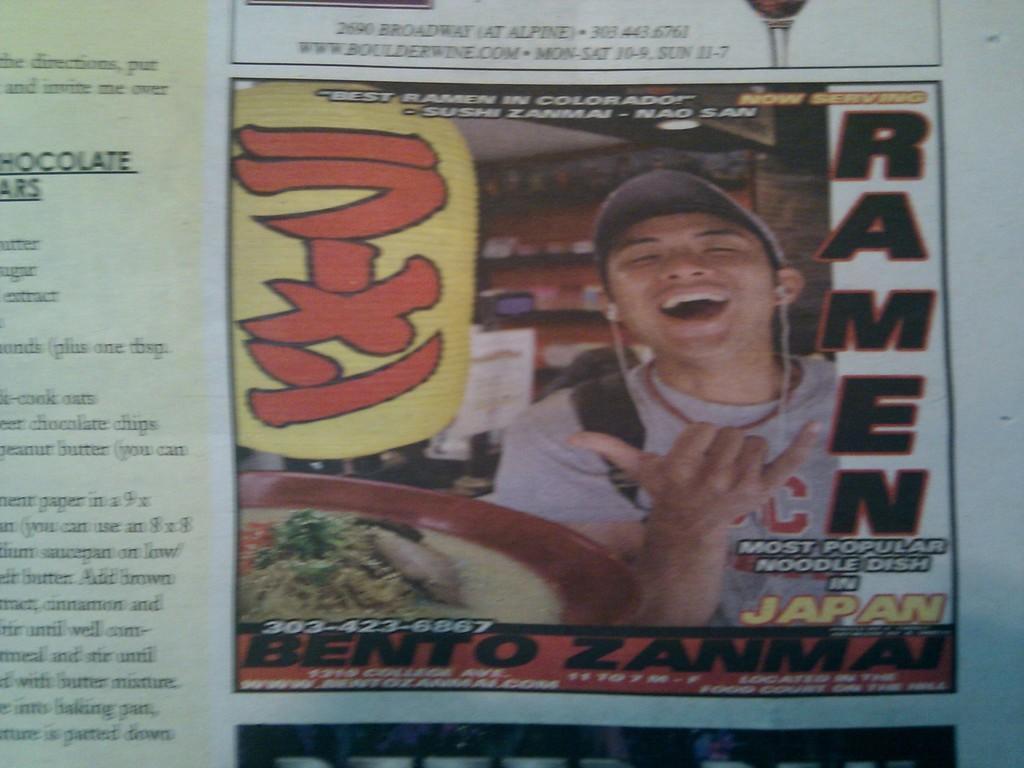What type of publication is depicted in the image? The image appears to be a newspaper. What elements can be found within the newspaper? The newspaper contains pictures and text. What type of comb is used to style the hair in the image? There is no hair or comb present in the image; it is a newspaper containing pictures and text. 